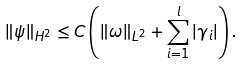<formula> <loc_0><loc_0><loc_500><loc_500>\| \psi \| _ { H ^ { 2 } } \leq C \left ( \| \omega \| _ { L ^ { 2 } } + \sum _ { i = 1 } ^ { l } | \gamma _ { i } | \right ) .</formula> 